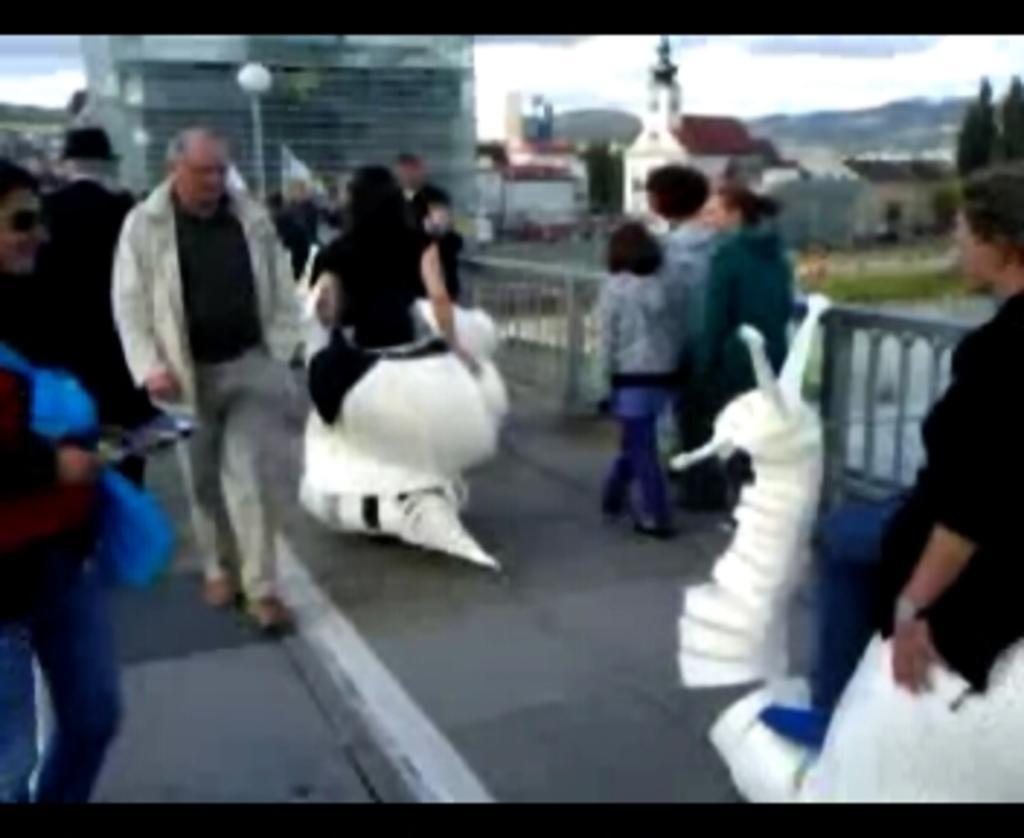Please provide a concise description of this image. In this image we can see people, road, fence, pole, light, buildings, and trees. In the background there is sky with clouds. 